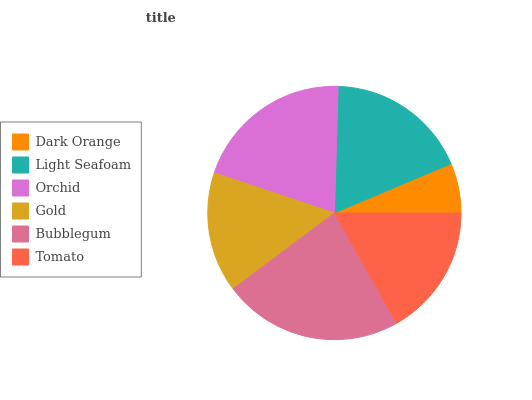Is Dark Orange the minimum?
Answer yes or no. Yes. Is Bubblegum the maximum?
Answer yes or no. Yes. Is Light Seafoam the minimum?
Answer yes or no. No. Is Light Seafoam the maximum?
Answer yes or no. No. Is Light Seafoam greater than Dark Orange?
Answer yes or no. Yes. Is Dark Orange less than Light Seafoam?
Answer yes or no. Yes. Is Dark Orange greater than Light Seafoam?
Answer yes or no. No. Is Light Seafoam less than Dark Orange?
Answer yes or no. No. Is Light Seafoam the high median?
Answer yes or no. Yes. Is Tomato the low median?
Answer yes or no. Yes. Is Tomato the high median?
Answer yes or no. No. Is Light Seafoam the low median?
Answer yes or no. No. 